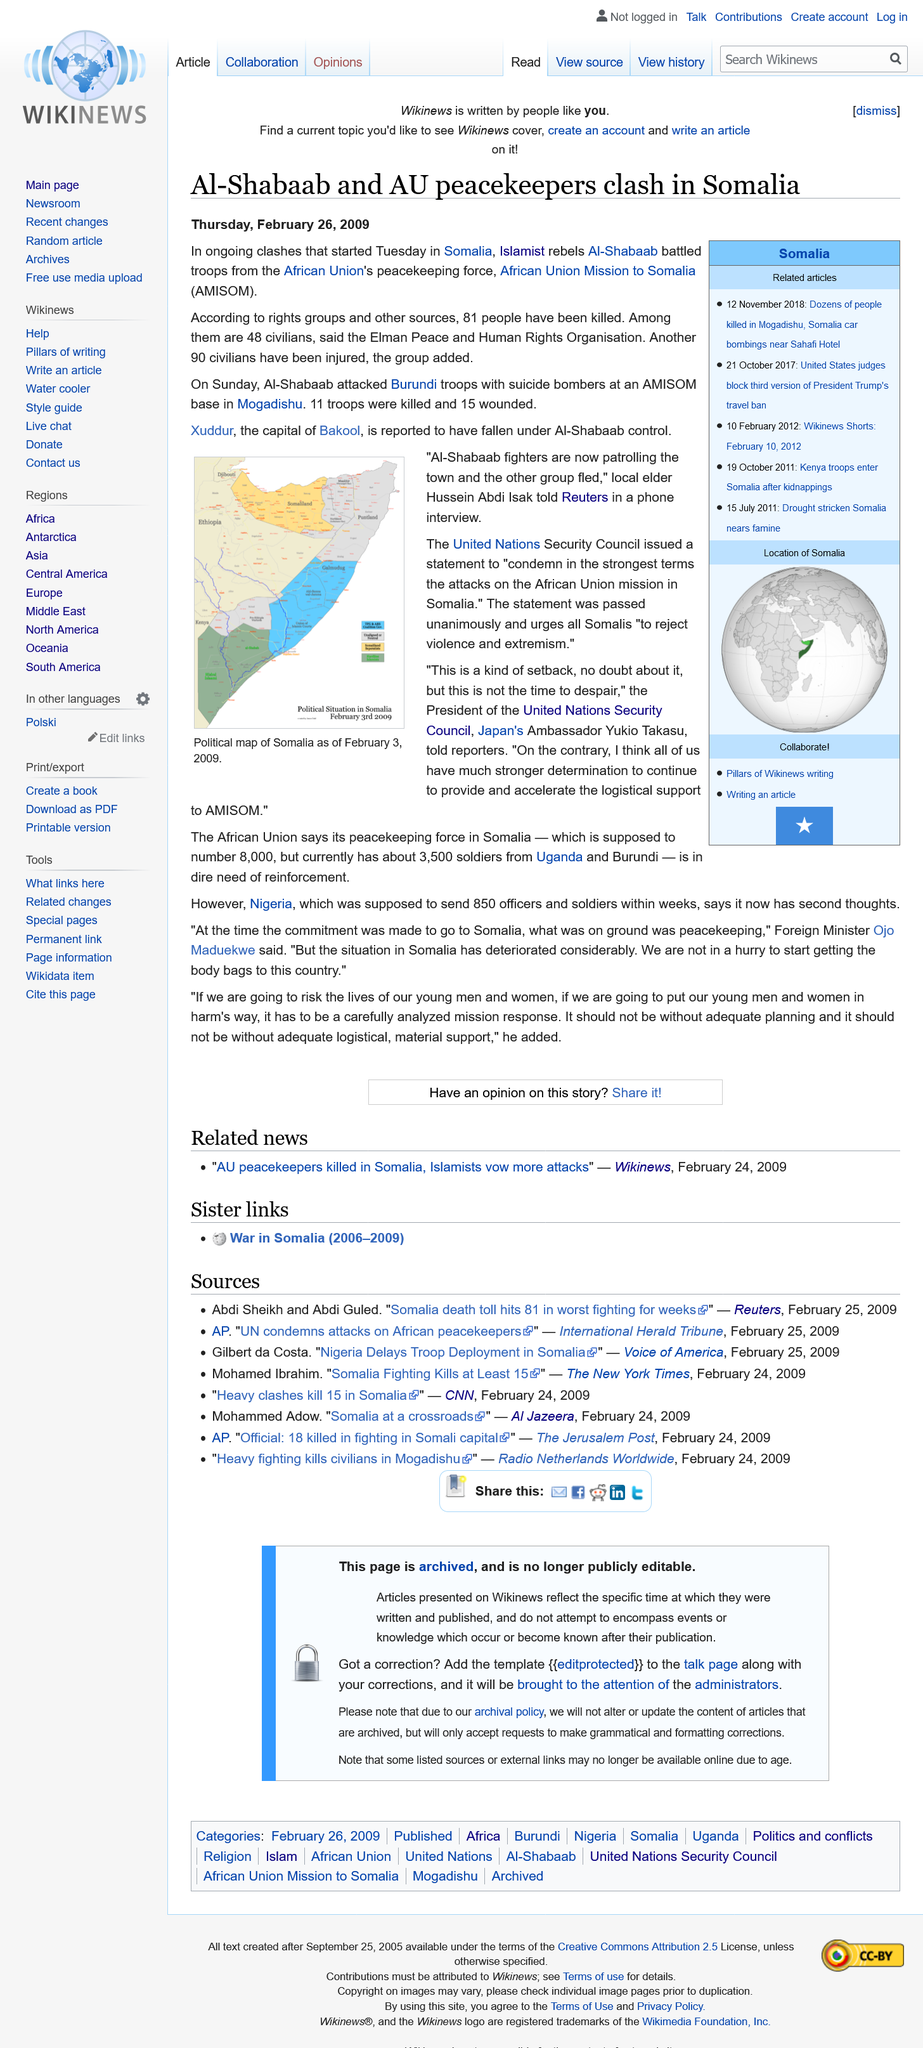List a handful of essential elements in this visual. According to credible sources, 81 individuals have lost their lives in the ongoing clashes that commenced on Tuesday in Somalia. The capital of Bakool is Xuddur. The President of the United Nations Security Council is Ambassador Yukio Takasu of Japan. On Tuesday, the ongoing clashes between Islamist rebels Al-Shabaab and troops from the African Union's peacekeeping force, the African Mission to Somalia, began in Somalia. The local elder, Hussein Abdi, has reported that Al-Shabaab fighters are currently patrolling the town. 